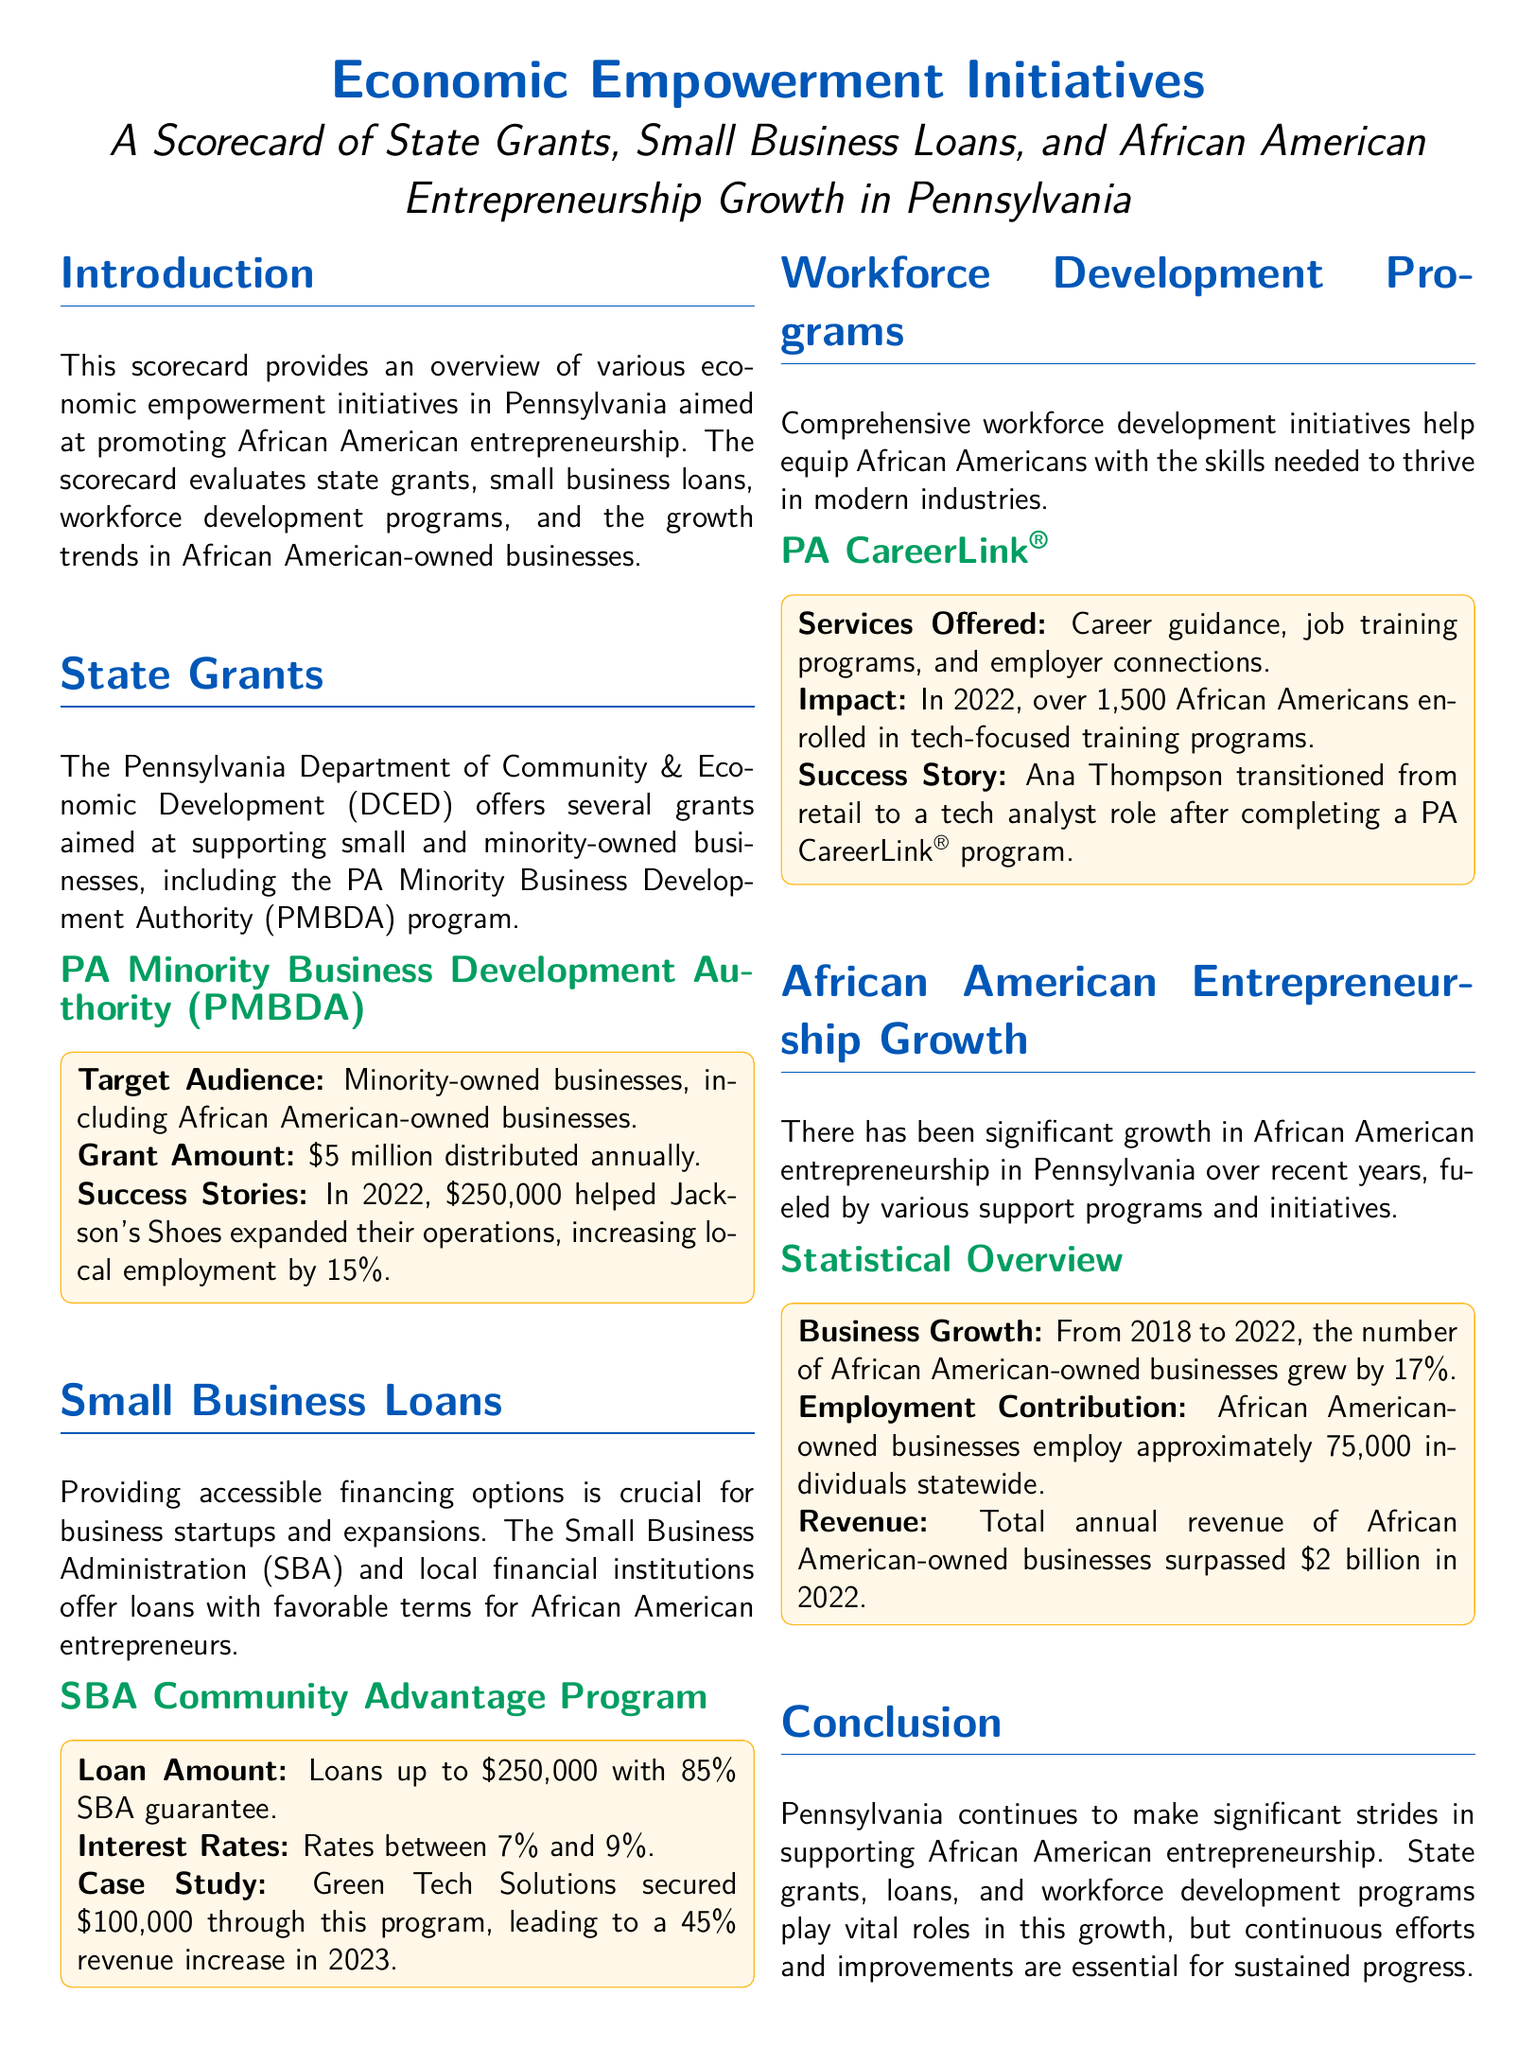What is the annual grant amount from the PA Minority Business Development Authority? The document specifies that the PA Minority Business Development Authority distributes $5 million annually.
Answer: $5 million What was the reported employment increase from Jackson's Shoes? The document mentions that Jackson's Shoes increased local employment by 15%.
Answer: 15% What is the loan amount offered by the SBA Community Advantage Program? According to the document, the SBA Community Advantage Program offers loans up to $250,000.
Answer: $250,000 How much did Green Tech Solutions secure through the SBA Community Advantage Program? The document states that Green Tech Solutions secured $100,000 through this program.
Answer: $100,000 How many African Americans enrolled in tech-focused training programs in 2022? The document indicates that over 1,500 African Americans enrolled in tech-focused training programs in 2022.
Answer: 1,500 What percentage growth was observed in African American-owned businesses from 2018 to 2022? The document confirms that the number of African American-owned businesses grew by 17%.
Answer: 17% What is the total annual revenue of African American-owned businesses as of 2022? The document states that the total annual revenue of these businesses surpassed $2 billion in 2022.
Answer: $2 billion What is the employment contribution of African American-owned businesses in Pennsylvania? The document states that these businesses employ approximately 75,000 individuals statewide.
Answer: 75,000 What program helps provide career guidance and job training for African Americans? The document mentions PA CareerLink as the program that offers career guidance and job training programs.
Answer: PA CareerLink 